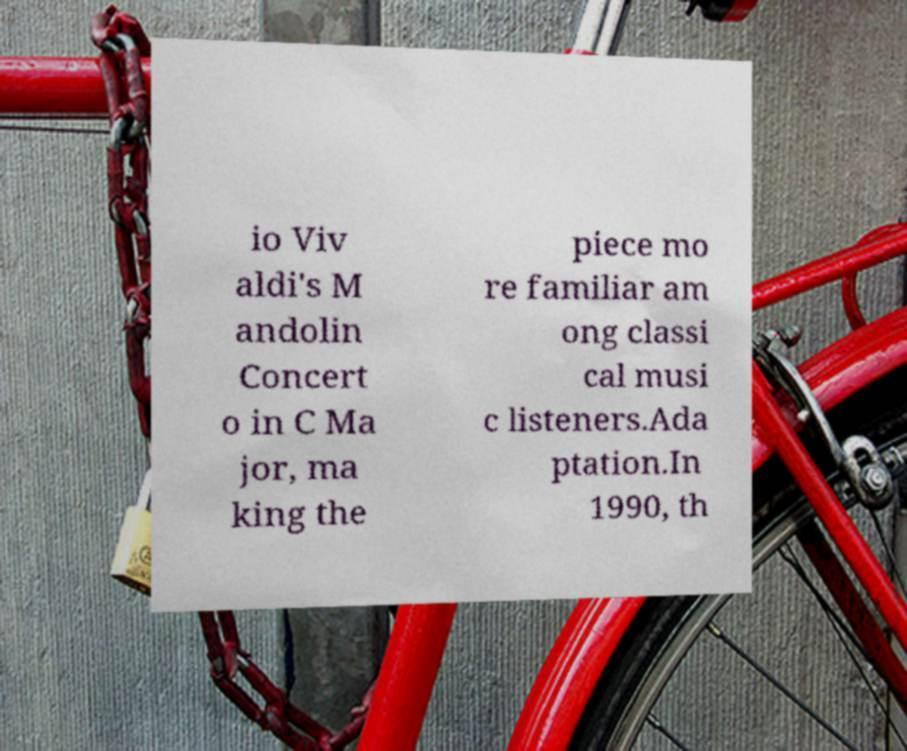What messages or text are displayed in this image? I need them in a readable, typed format. io Viv aldi's M andolin Concert o in C Ma jor, ma king the piece mo re familiar am ong classi cal musi c listeners.Ada ptation.In 1990, th 